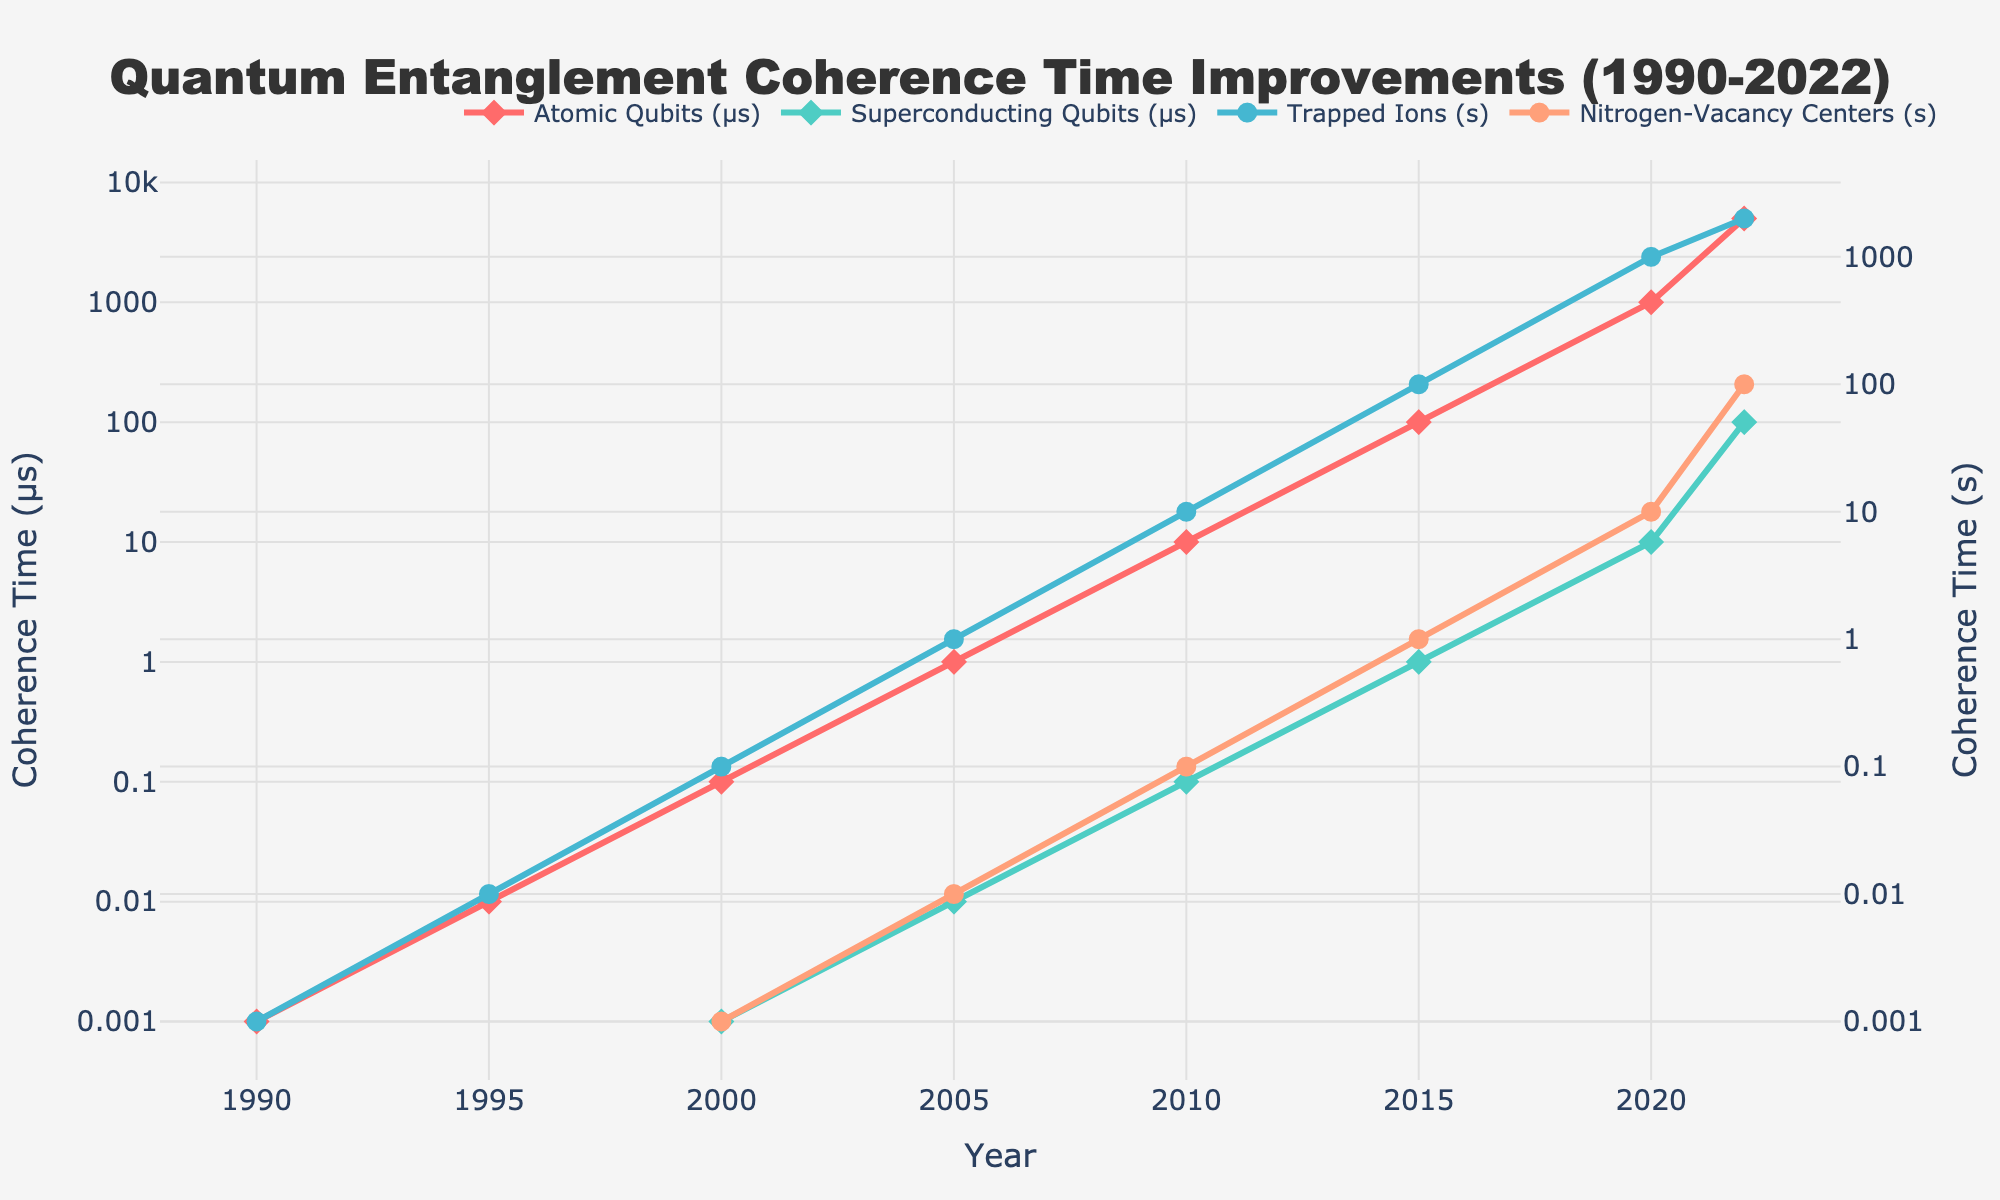How has the coherence time for Atomic Qubits changed from 1990 to 2022? To find the change, observe the values for Atomic Qubits in 1990 and 2022. In 1990, the coherence time was 0.001 μs. By 2022, it had increased to 5000 μs. Therefore, the change is 5000 μs - 0.001 μs.
Answer: Increased by 4999.999 μs Which type of qubit had the highest coherence time in 2020? Compare the coherence times for all qubit types in 2020. The values are Atomic Qubits (1000 μs), Superconducting Qubits (10 μs), Trapped Ions (1000 s), and Nitrogen-Vacancy Centers (10 s). The highest value among these is Trapped Ions at 1000 s.
Answer: Trapped Ions Between which years did Superconducting Qubits show the most significant increase in coherence time? Check the values for Superconducting Qubits across different years to identify the most significant increase. From 2015 to 2020, the coherence time increased from 1 μs to 10 μs, which is a 9 μs increase. From 2020 to 2022, the coherence time increased from 10 μs to 100 μs, which is a 90 μs increase. The most significant increase is hence between 2020 and 2022.
Answer: 2020 to 2022 What is the trend in coherence time improvements for Nitrogen-Vacancy Centers from 1990 to 2022, and how does it compare to Trapped Ions over the same period? For Nitrogen-Vacancy Centers, coherence times started at N/A in 1990, 1995, and 2000, then started appearing from 2005 at 0.01 s and gradually increasing to 100 s by 2022. For Trapped Ions, coherence times started at 0.001 s in 1990 and increased to 2000 s by 2022. Both cohorts show consistent improvement, but Trapped Ions had a higher starting point and ended with a significantly higher value.
Answer: Both show consistent improvements, but Trapped Ions had higher coherence times throughout In what year did Atomic Qubits first achieve a coherence time of at least 1 μs? Check the Atomic Qubits data for when its coherence time first reached or exceeded 1 μs. In 2005, the coherence time for Atomic Qubits was exactly 1 μs.
Answer: 2005 How does the coherence time for Trapped Ions in 2000 compare to that of Superconducting Qubits in the same year? Look at the coherence times for both Trapped Ions and Superconducting Qubits in 2000. For Trapped Ions, it was 0.1 s, and for Superconducting Qubits, it was 0.001 μs. A second is equal to 1,000,000 μs, so 0.1 s equals 100,000 μs, which is much larger than 0.001 μs.
Answer: Trapped Ions had a much higher coherence time What is the approximate average coherence time for Superconducting Qubits in the years provided? To calculate the average, sum the coherence times and divide by the number of years. The values are 0.001 μs (2000), 0.01 μs (2005), 0.1 μs (2010), 1 μs (2015), 10 μs (2020), and 100 μs (2022). The sum of these values is 111.111 μs, divided by 6 gives approximately 18.518 μs.
Answer: Approximately 18.518 μs 